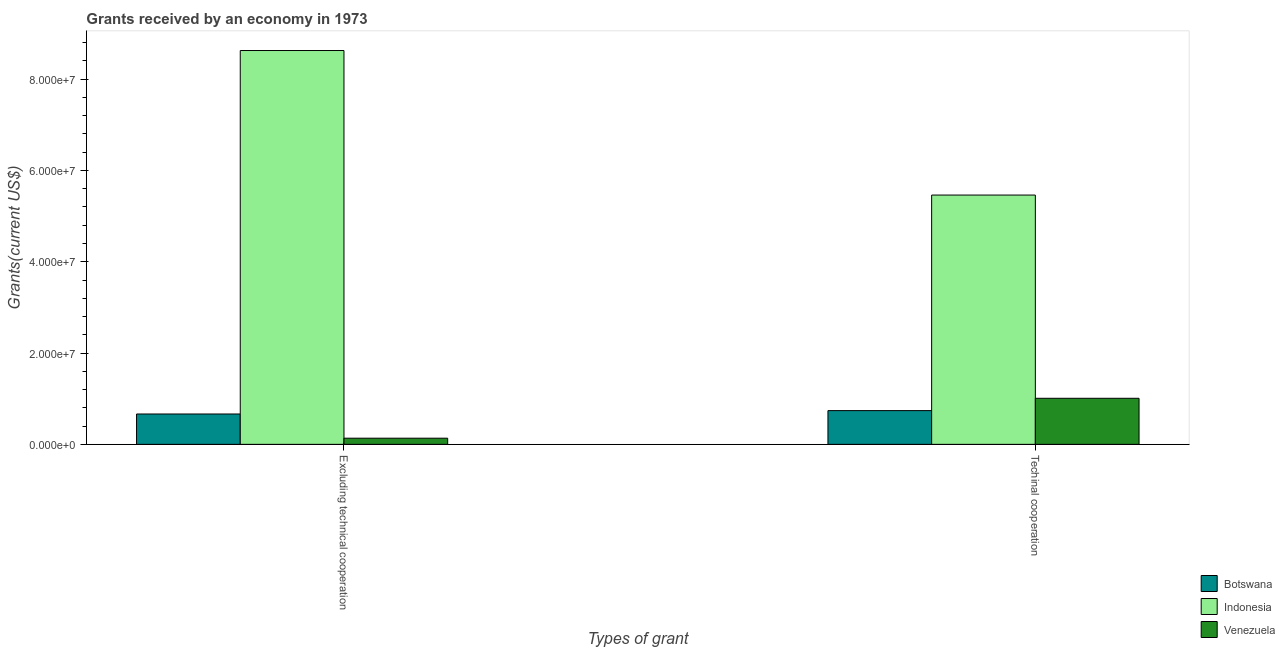How many groups of bars are there?
Your answer should be very brief. 2. Are the number of bars per tick equal to the number of legend labels?
Offer a very short reply. Yes. How many bars are there on the 2nd tick from the right?
Your response must be concise. 3. What is the label of the 1st group of bars from the left?
Give a very brief answer. Excluding technical cooperation. What is the amount of grants received(including technical cooperation) in Venezuela?
Your answer should be very brief. 1.01e+07. Across all countries, what is the maximum amount of grants received(including technical cooperation)?
Ensure brevity in your answer.  5.46e+07. Across all countries, what is the minimum amount of grants received(including technical cooperation)?
Offer a terse response. 7.39e+06. In which country was the amount of grants received(excluding technical cooperation) minimum?
Keep it short and to the point. Venezuela. What is the total amount of grants received(including technical cooperation) in the graph?
Offer a very short reply. 7.21e+07. What is the difference between the amount of grants received(including technical cooperation) in Indonesia and that in Venezuela?
Provide a short and direct response. 4.45e+07. What is the difference between the amount of grants received(excluding technical cooperation) in Indonesia and the amount of grants received(including technical cooperation) in Venezuela?
Keep it short and to the point. 7.62e+07. What is the average amount of grants received(including technical cooperation) per country?
Provide a succinct answer. 2.40e+07. What is the difference between the amount of grants received(excluding technical cooperation) and amount of grants received(including technical cooperation) in Venezuela?
Provide a succinct answer. -8.74e+06. In how many countries, is the amount of grants received(excluding technical cooperation) greater than 60000000 US$?
Offer a terse response. 1. What is the ratio of the amount of grants received(including technical cooperation) in Botswana to that in Venezuela?
Your answer should be very brief. 0.73. In how many countries, is the amount of grants received(excluding technical cooperation) greater than the average amount of grants received(excluding technical cooperation) taken over all countries?
Offer a very short reply. 1. How many bars are there?
Give a very brief answer. 6. Are all the bars in the graph horizontal?
Keep it short and to the point. No. Where does the legend appear in the graph?
Your response must be concise. Bottom right. What is the title of the graph?
Keep it short and to the point. Grants received by an economy in 1973. What is the label or title of the X-axis?
Your answer should be very brief. Types of grant. What is the label or title of the Y-axis?
Give a very brief answer. Grants(current US$). What is the Grants(current US$) of Botswana in Excluding technical cooperation?
Your answer should be compact. 6.65e+06. What is the Grants(current US$) of Indonesia in Excluding technical cooperation?
Provide a short and direct response. 8.63e+07. What is the Grants(current US$) in Venezuela in Excluding technical cooperation?
Your answer should be compact. 1.35e+06. What is the Grants(current US$) of Botswana in Techinal cooperation?
Keep it short and to the point. 7.39e+06. What is the Grants(current US$) of Indonesia in Techinal cooperation?
Provide a succinct answer. 5.46e+07. What is the Grants(current US$) of Venezuela in Techinal cooperation?
Keep it short and to the point. 1.01e+07. Across all Types of grant, what is the maximum Grants(current US$) of Botswana?
Keep it short and to the point. 7.39e+06. Across all Types of grant, what is the maximum Grants(current US$) in Indonesia?
Provide a short and direct response. 8.63e+07. Across all Types of grant, what is the maximum Grants(current US$) of Venezuela?
Make the answer very short. 1.01e+07. Across all Types of grant, what is the minimum Grants(current US$) in Botswana?
Ensure brevity in your answer.  6.65e+06. Across all Types of grant, what is the minimum Grants(current US$) in Indonesia?
Your response must be concise. 5.46e+07. Across all Types of grant, what is the minimum Grants(current US$) of Venezuela?
Offer a very short reply. 1.35e+06. What is the total Grants(current US$) in Botswana in the graph?
Make the answer very short. 1.40e+07. What is the total Grants(current US$) of Indonesia in the graph?
Offer a very short reply. 1.41e+08. What is the total Grants(current US$) of Venezuela in the graph?
Make the answer very short. 1.14e+07. What is the difference between the Grants(current US$) of Botswana in Excluding technical cooperation and that in Techinal cooperation?
Make the answer very short. -7.40e+05. What is the difference between the Grants(current US$) of Indonesia in Excluding technical cooperation and that in Techinal cooperation?
Provide a succinct answer. 3.17e+07. What is the difference between the Grants(current US$) of Venezuela in Excluding technical cooperation and that in Techinal cooperation?
Provide a short and direct response. -8.74e+06. What is the difference between the Grants(current US$) of Botswana in Excluding technical cooperation and the Grants(current US$) of Indonesia in Techinal cooperation?
Provide a succinct answer. -4.80e+07. What is the difference between the Grants(current US$) in Botswana in Excluding technical cooperation and the Grants(current US$) in Venezuela in Techinal cooperation?
Provide a succinct answer. -3.44e+06. What is the difference between the Grants(current US$) of Indonesia in Excluding technical cooperation and the Grants(current US$) of Venezuela in Techinal cooperation?
Offer a very short reply. 7.62e+07. What is the average Grants(current US$) of Botswana per Types of grant?
Ensure brevity in your answer.  7.02e+06. What is the average Grants(current US$) of Indonesia per Types of grant?
Provide a succinct answer. 7.04e+07. What is the average Grants(current US$) of Venezuela per Types of grant?
Your answer should be very brief. 5.72e+06. What is the difference between the Grants(current US$) of Botswana and Grants(current US$) of Indonesia in Excluding technical cooperation?
Offer a very short reply. -7.96e+07. What is the difference between the Grants(current US$) of Botswana and Grants(current US$) of Venezuela in Excluding technical cooperation?
Your answer should be compact. 5.30e+06. What is the difference between the Grants(current US$) of Indonesia and Grants(current US$) of Venezuela in Excluding technical cooperation?
Offer a terse response. 8.49e+07. What is the difference between the Grants(current US$) in Botswana and Grants(current US$) in Indonesia in Techinal cooperation?
Keep it short and to the point. -4.72e+07. What is the difference between the Grants(current US$) of Botswana and Grants(current US$) of Venezuela in Techinal cooperation?
Provide a short and direct response. -2.70e+06. What is the difference between the Grants(current US$) of Indonesia and Grants(current US$) of Venezuela in Techinal cooperation?
Offer a very short reply. 4.45e+07. What is the ratio of the Grants(current US$) of Botswana in Excluding technical cooperation to that in Techinal cooperation?
Offer a terse response. 0.9. What is the ratio of the Grants(current US$) in Indonesia in Excluding technical cooperation to that in Techinal cooperation?
Your answer should be compact. 1.58. What is the ratio of the Grants(current US$) in Venezuela in Excluding technical cooperation to that in Techinal cooperation?
Provide a succinct answer. 0.13. What is the difference between the highest and the second highest Grants(current US$) of Botswana?
Offer a terse response. 7.40e+05. What is the difference between the highest and the second highest Grants(current US$) of Indonesia?
Keep it short and to the point. 3.17e+07. What is the difference between the highest and the second highest Grants(current US$) of Venezuela?
Provide a succinct answer. 8.74e+06. What is the difference between the highest and the lowest Grants(current US$) of Botswana?
Make the answer very short. 7.40e+05. What is the difference between the highest and the lowest Grants(current US$) in Indonesia?
Offer a very short reply. 3.17e+07. What is the difference between the highest and the lowest Grants(current US$) in Venezuela?
Provide a short and direct response. 8.74e+06. 